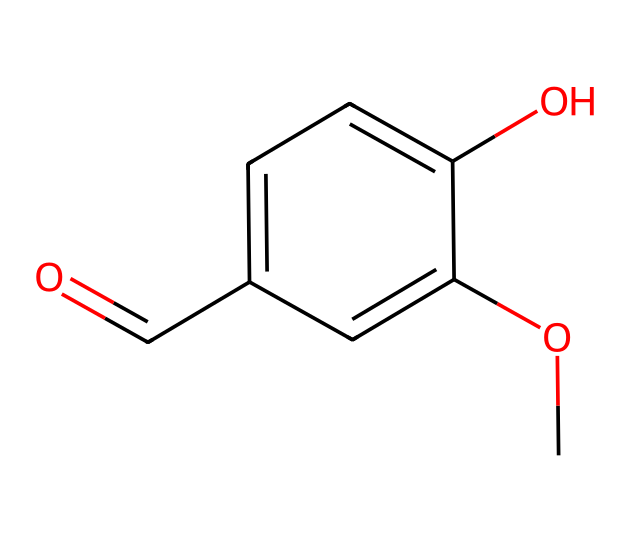What is the common name of this compound? The provided SMILES (COc1cc(C=O)ccc1O) corresponds to vanillin, which is the common name for this chemical.
Answer: vanillin How many benzene rings are present in this structure? Analyzing the chemical structure, there is one benzene ring (indicated by the six-membered carbon ring) present in the SMILES representation.
Answer: one What functional groups are present in vanillin? The structure features a methoxy group (-OCH3) and an aldehyde group (-CHO), which are the functional groups present in this compound.
Answer: methoxy and aldehyde How many carbon atoms are in vanillin? Counting the carbon atoms in the SMILES representation (COc1cc(C=O)ccc1O), there are eight carbon atoms in total.
Answer: eight What type of functional group characterizes vanillin as an aldehyde? The presence of the aldehyde group, indicated by the -C=O part of the structure, characterizes vanillin as an aldehyde.
Answer: aldehyde Is vanillin polar or nonpolar? The presence of polar groups like the aldehyde and hydroxyl (-OH) suggests that vanillin is polar overall due to its ability to form hydrogen bonds.
Answer: polar In what type of product is vanillin commonly used? Vanillin is commonly used in flavoring food products, such as vanilla-flavored ice cream and baked goods.
Answer: flavoring agent 